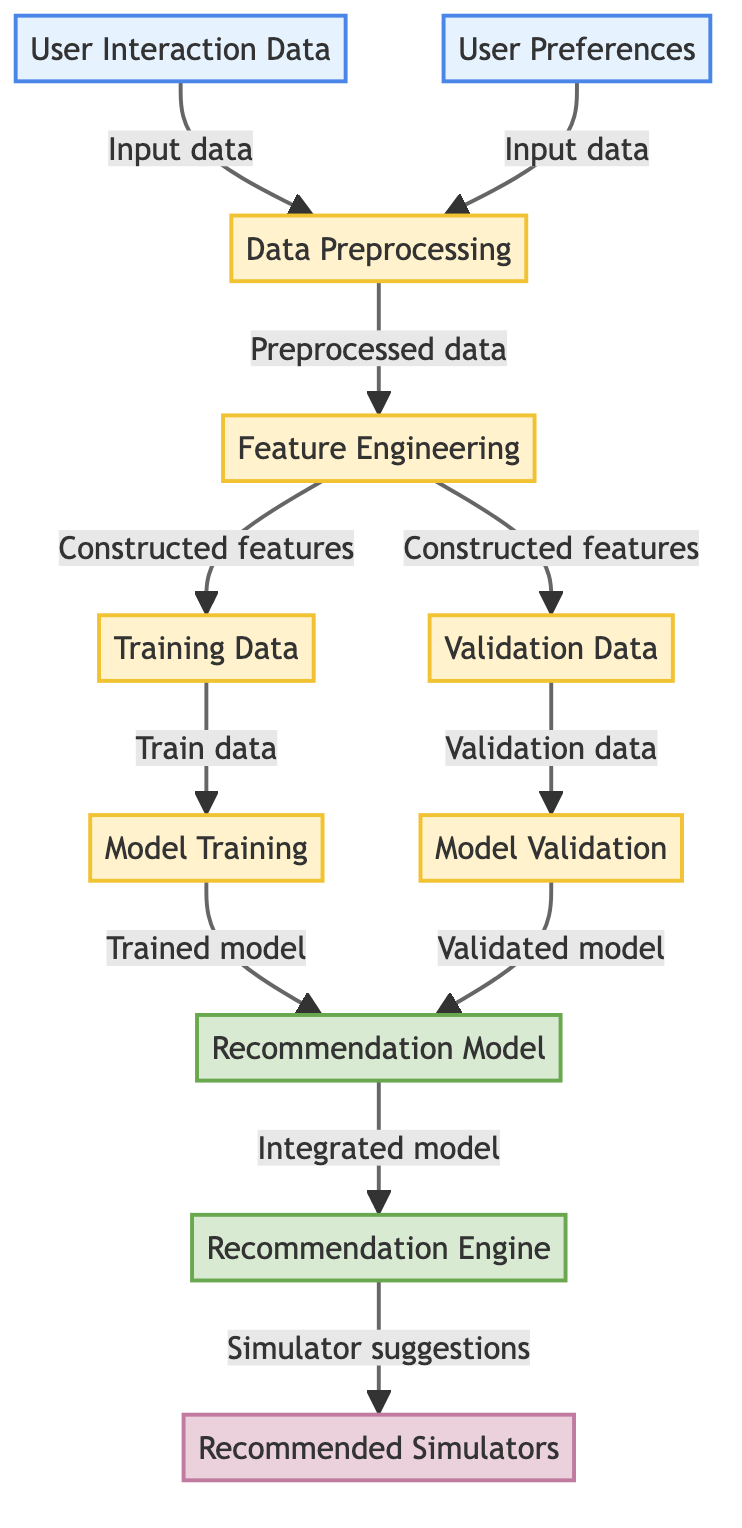What are the two types of input data in the diagram? The diagram shows two input data types: "User Interaction Data" and "User Preferences," which are represented by nodes A and B.
Answer: User Interaction Data, User Preferences How many processing steps are indicated in the workflow? The diagram contains four processing steps: "Data Preprocessing," "Feature Engineering," "Model Training," and "Model Validation," which are represented by nodes C, D, H, and I.
Answer: Four What does node G represent in the diagram? Node G is labeled as "Recommendation Model," which indicates that it is the core model used to generate recommendations based on the training data.
Answer: Recommendation Model Which node produces the final output? The final output is produced by node K, which is labeled "Recommended Simulators," indicating it provides the suggestions based on the recommendations engine.
Answer: Recommended Simulators What is the relationship between nodes E and H? Node E, labeled "Training Data," provides input to node H, labeled "Model Training." This indicates that the training data is necessary for the model training process.
Answer: Training Data to Model Training What type of data does node D create? Node D, labeled "Feature Engineering," creates "Constructed features," which serve as the inputs for further processing of training and validation.
Answer: Constructed features How many outputs does the recommendation model generate? The recommendation model (node J) generates a single output labeled "Simulator suggestions" which is directed to node K.
Answer: One What step occurs after the model validation? After model validation represented in node I, the validated model is sent to node G, labeled "Recommendation Model" for integration, indicating that the model is ready for use.
Answer: Integrated model What are the two components that feed into the data preprocessing? The two components that feed into "Data Preprocessing" (node C) are "User Interaction Data" (node A) and "User Preferences" (node B).
Answer: User Interaction Data, User Preferences 